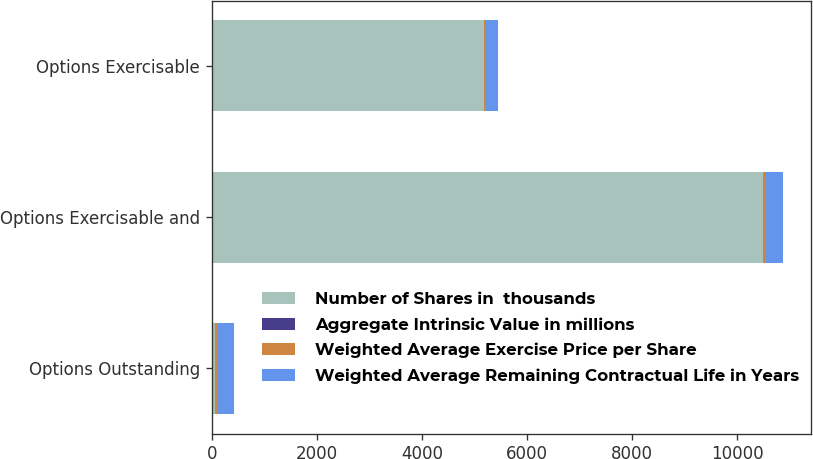Convert chart. <chart><loc_0><loc_0><loc_500><loc_500><stacked_bar_chart><ecel><fcel>Options Outstanding<fcel>Options Exercisable and<fcel>Options Exercisable<nl><fcel>Number of Shares in  thousands<fcel>52.67<fcel>10496<fcel>5177<nl><fcel>Aggregate Intrinsic Value in millions<fcel>5.21<fcel>5.08<fcel>2.84<nl><fcel>Weighted Average Exercise Price per Share<fcel>52.67<fcel>51.96<fcel>38.18<nl><fcel>Weighted Average Remaining Contractual Life in Years<fcel>322<fcel>317<fcel>227<nl></chart> 